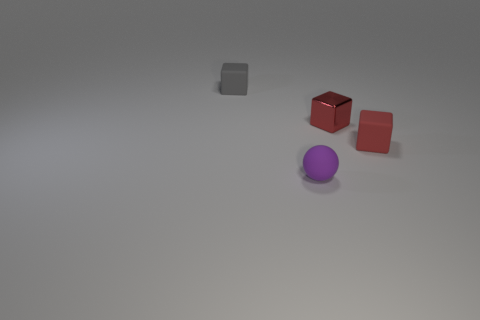What material is the other red thing that is the same shape as the tiny red metal thing?
Provide a succinct answer. Rubber. There is a red object that is right of the small red metal cube; is its shape the same as the rubber object in front of the red rubber block?
Provide a short and direct response. No. There is a purple rubber object that is the same size as the red matte block; what shape is it?
Your answer should be very brief. Sphere. Do the gray block that is left of the tiny purple thing and the small red object that is behind the tiny red rubber block have the same material?
Your response must be concise. No. Is there a small red rubber cube that is to the right of the matte object on the left side of the purple matte object?
Your response must be concise. Yes. There is a small ball that is the same material as the tiny gray thing; what is its color?
Your response must be concise. Purple. Is the number of big red blocks greater than the number of gray blocks?
Provide a succinct answer. No. What number of things are either blocks that are behind the red metallic thing or big cyan shiny balls?
Offer a terse response. 1. Is there a blue shiny cube that has the same size as the red metallic thing?
Ensure brevity in your answer.  No. Are there fewer tiny gray blocks than small rubber objects?
Offer a terse response. Yes. 